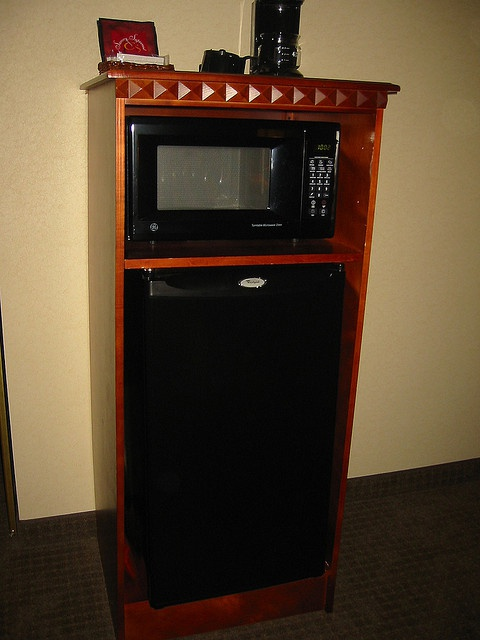Describe the objects in this image and their specific colors. I can see refrigerator in olive, black, maroon, darkgray, and gray tones, microwave in olive, black, gray, and maroon tones, and book in olive and tan tones in this image. 